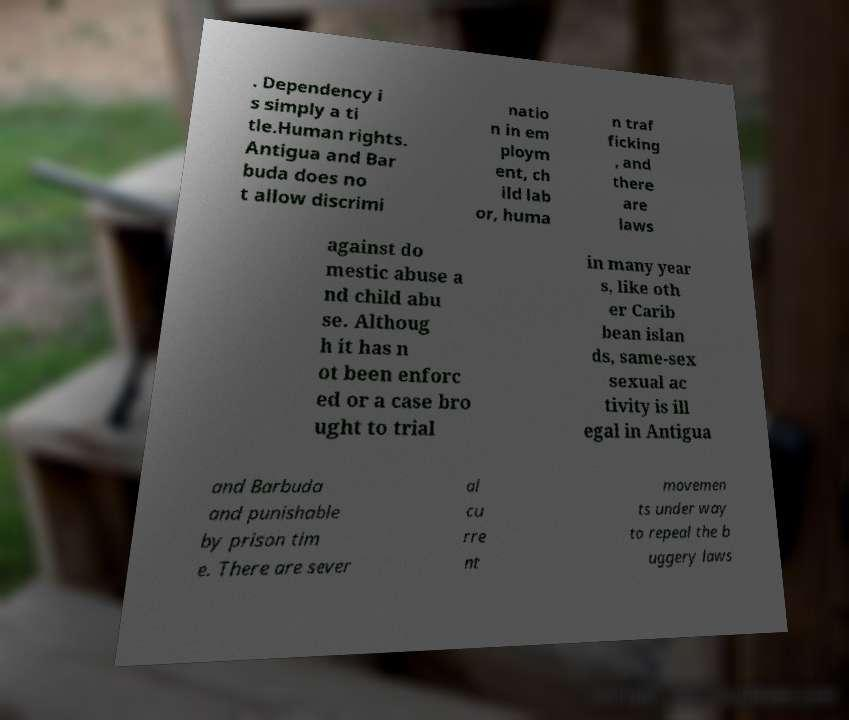Can you accurately transcribe the text from the provided image for me? . Dependency i s simply a ti tle.Human rights. Antigua and Bar buda does no t allow discrimi natio n in em ploym ent, ch ild lab or, huma n traf ficking , and there are laws against do mestic abuse a nd child abu se. Althoug h it has n ot been enforc ed or a case bro ught to trial in many year s, like oth er Carib bean islan ds, same-sex sexual ac tivity is ill egal in Antigua and Barbuda and punishable by prison tim e. There are sever al cu rre nt movemen ts under way to repeal the b uggery laws 